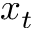Convert formula to latex. <formula><loc_0><loc_0><loc_500><loc_500>x _ { t }</formula> 